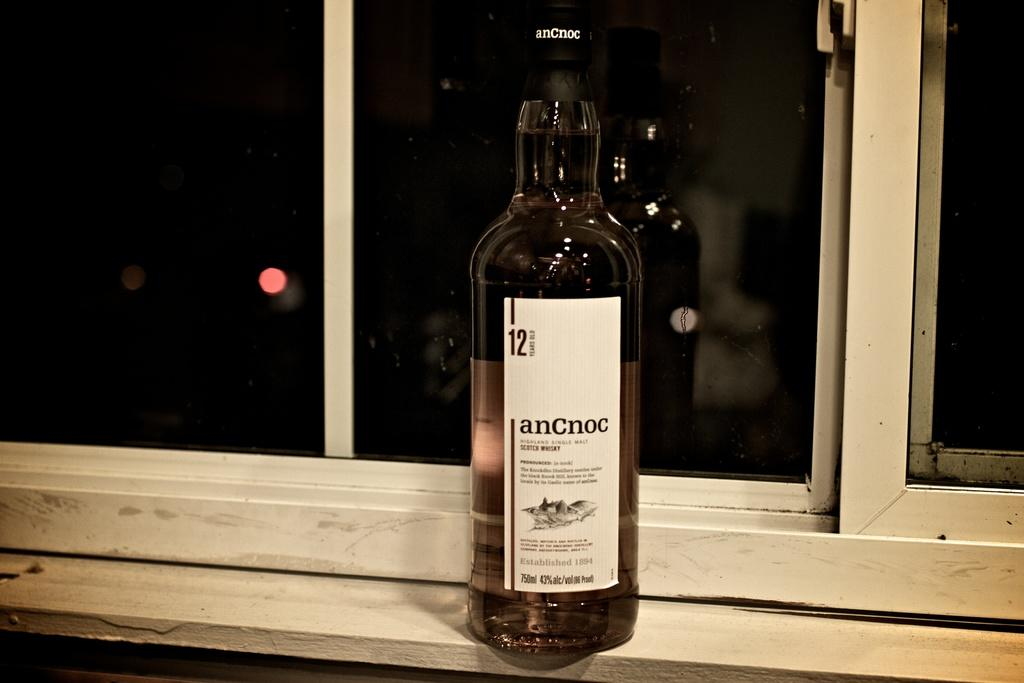<image>
Offer a succinct explanation of the picture presented. A bottle of wine with the number 12 on it and says anCnoc sitting on a window ledge. 